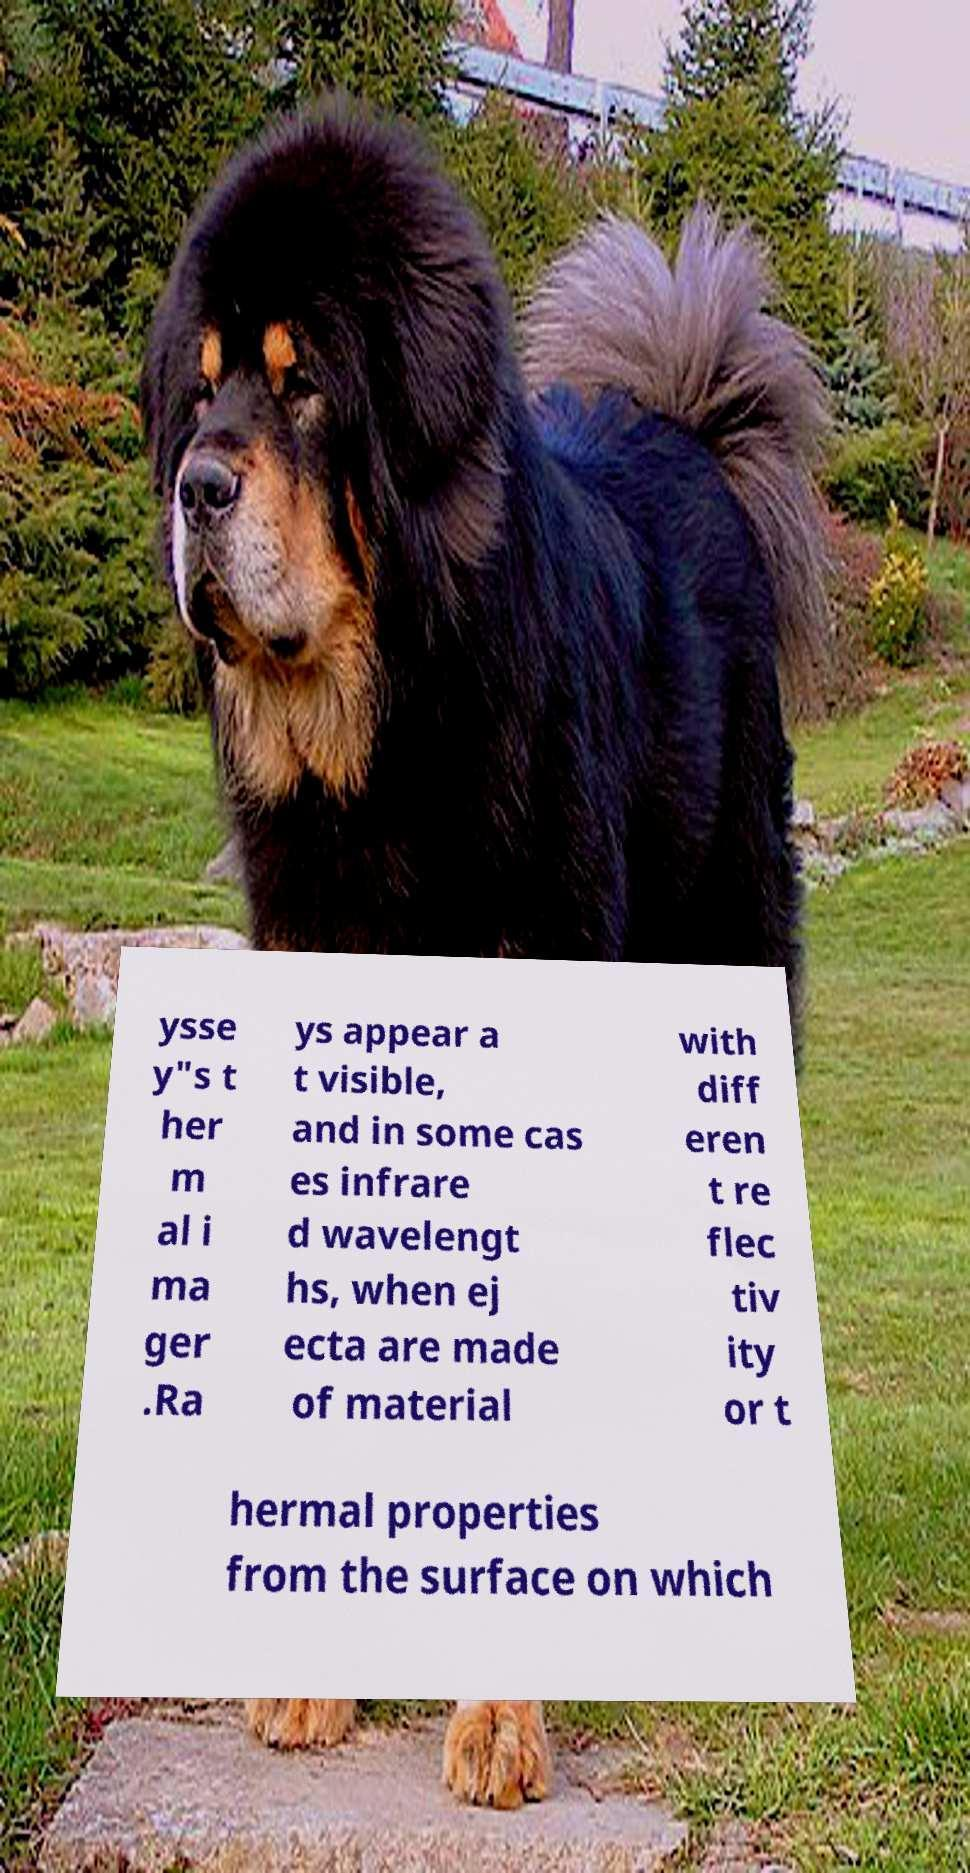For documentation purposes, I need the text within this image transcribed. Could you provide that? ysse y"s t her m al i ma ger .Ra ys appear a t visible, and in some cas es infrare d wavelengt hs, when ej ecta are made of material with diff eren t re flec tiv ity or t hermal properties from the surface on which 